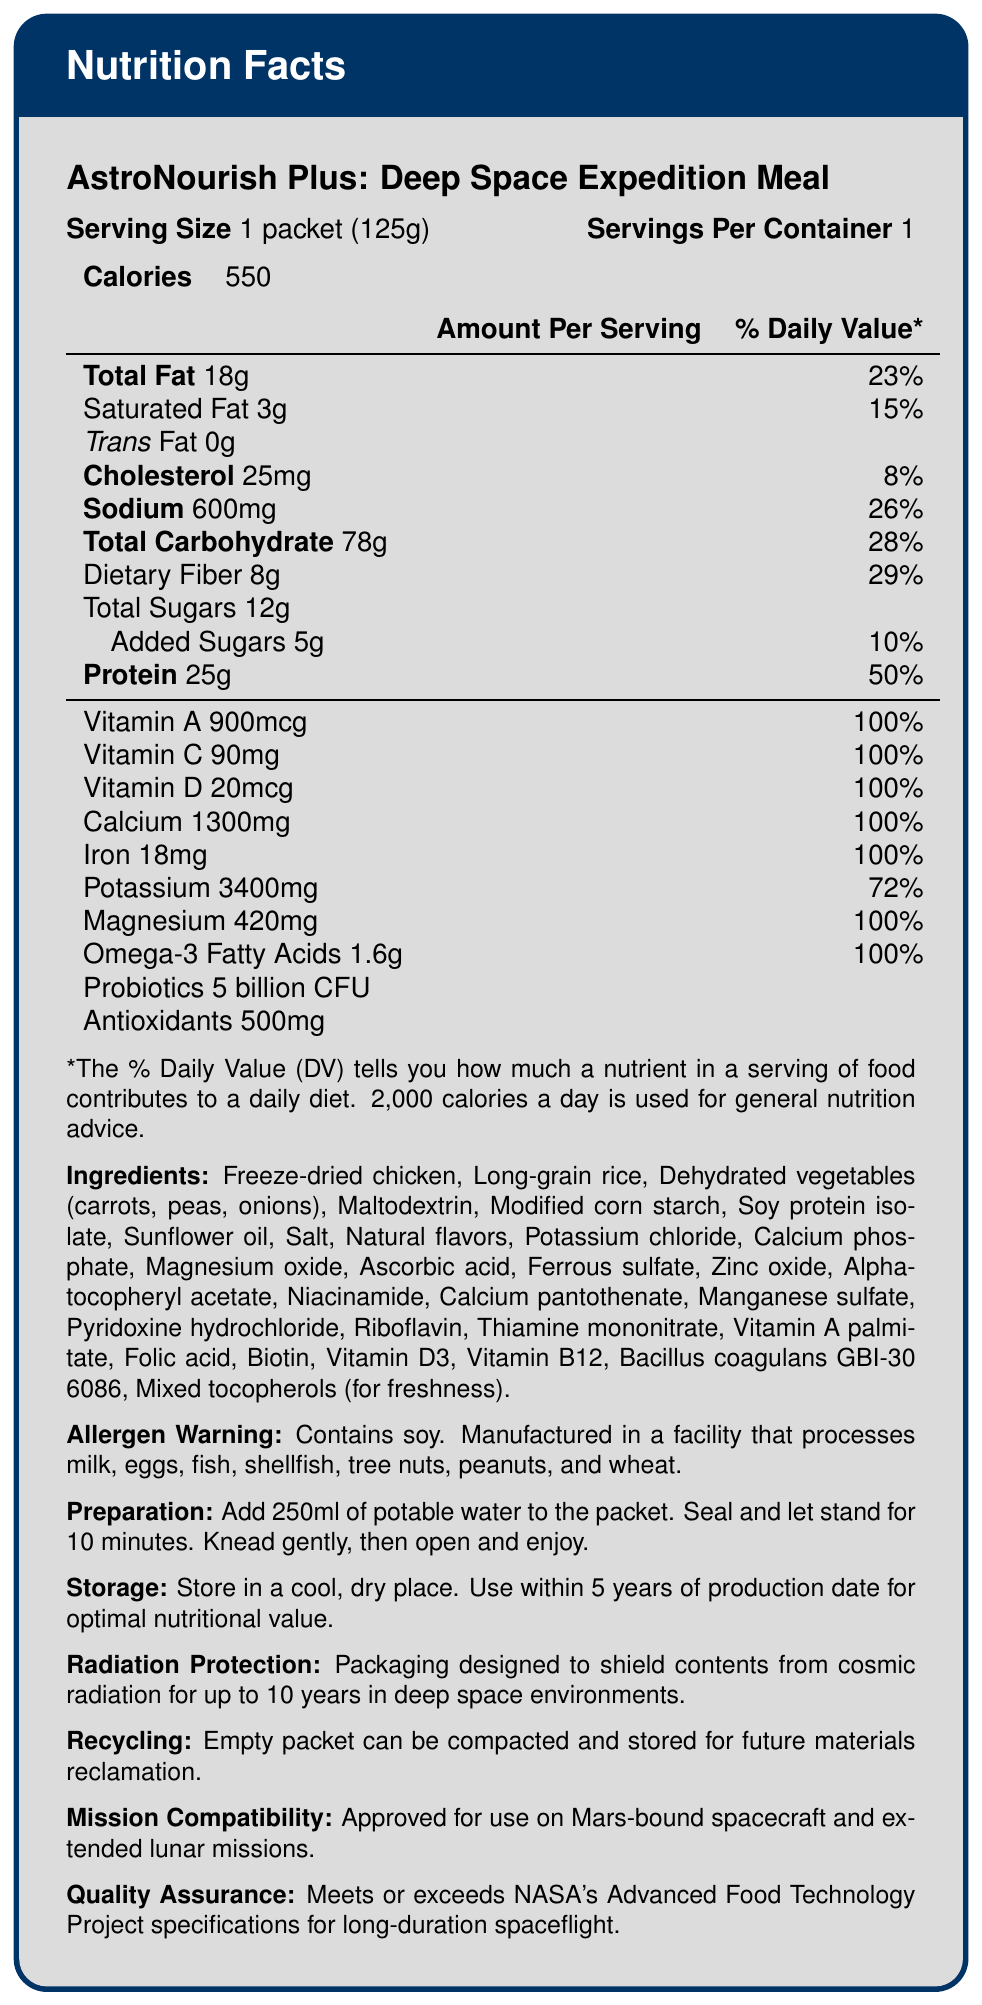what is the serving size? The serving size is listed as 1 packet, which weighs 125 grams.
Answer: 1 packet (125g) how many servings are in one container? The document states that there is 1 serving per container.
Answer: 1 how many calories are in one serving? It is stated in the document that there are 550 calories per serving.
Answer: 550 what is the dietary fiber content per serving? The document specifies that each serving contains 8 grams of dietary fiber.
Answer: 8g what percent daily value of protein does one serving provide? The document indicates that one serving provides 50% of the daily value for protein.
Answer: 50% how many grams of total sugars are in one serving? The document lists that there are 12 grams of total sugars in a serving.
Answer: 12g which vitamin is present at 100% daily value per serving? The document shows that these vitamins and minerals are provided at 100% of the daily value per serving.
Answer: Vitamin A, Vitamin C, Vitamin D, Calcium, Iron, Magnesium, Omega-3 Fatty Acids how much sodium is there in a serving of the meal? The amount of sodium per serving is listed as 600 milligrams.
Answer: 600mg which of the following ingredients is not included in the meal? A. Freeze-dried chicken B. Dehydrated vegetables C. Preservatives D. Soy protein isolate The document lists the ingredients and does not include preservatives.
Answer: C. Preservatives which vitamin or mineral has the highest daily percentage value per serving? 1. Potassium 2. Iron 3. Magnesium 4. Calcium Magnesium is present at 100% daily value, but calcium is also at 100%. Between these, calcium has a higher milligram weight listed per serving.
Answer: 4. Calcium What are the main allergens listed in the meal packet? The document has an allergen warning that specifically mentions soy.
Answer: Soy what is the calorie count per container? A. 300 B. 450 C. 550 D. 700 Each serving, which is also one container, contains 550 calories.
Answer: C. 550 is this meal suitable for vegetarians? The document lists freeze-dried chicken as an ingredient, making it unsuitable for vegetarians.
Answer: No does the meal packet contain added sugars? The document specifies that there are 5 grams of added sugars per serving.
Answer: Yes how are the meals protected from cosmic radiation? The document states that the packaging is designed for radiation protection for up to 10 years.
Answer: Packaging designed to shield contents from cosmic radiation for up to 10 years in deep space environments summarize the main nutritional details and mission compatibility features of the meal packet. The document outlines that each serving of the meal packet is nutritionally rich, providing beneficial amounts for essential nutrients and has specific design considerations for space exploration missions.
Answer: The meal packet provides 550 calories with high amounts of vitamins, minerals, protein, and fiber. It contains 100% daily values for multiple essential nutrients and is fortified with omega-3 fatty acids and probiotics. The packet is designed for long-term storage, offering protection against cosmic radiation and being approved for Mars and lunar missions. what is the source of probiotics included in the meal? The document mentions Bacillus coagulans GBI-30 6086 as the source of probiotics.
Answer: Bacillus coagulans GBI-30 6086 what is the daily value percentage of potassium in one serving? The document indicates that one serving provides 72% of the daily value for potassium.
Answer: 72% how should the meal be prepared? The document provides these steps as the preparation instructions.
Answer: Add 250ml of potable water to the packet. Seal and let stand for 10 minutes. Knead gently, then open and enjoy. what is the weight of the calcium content per serving? The document specifies that there are 1300 milligrams of calcium per serving.
Answer: 1300mg what is the primary function of mixed tocopherols in the ingredients list? The document mentions that mixed tocopherols are used for freshness.
Answer: For freshness is the nutritional information sufficient to determine the specific nutrient proportions for different mission durations? While the document provides nutritional details per serving, it does not include information on specific requirements based on mission duration.
Answer: Not enough information 